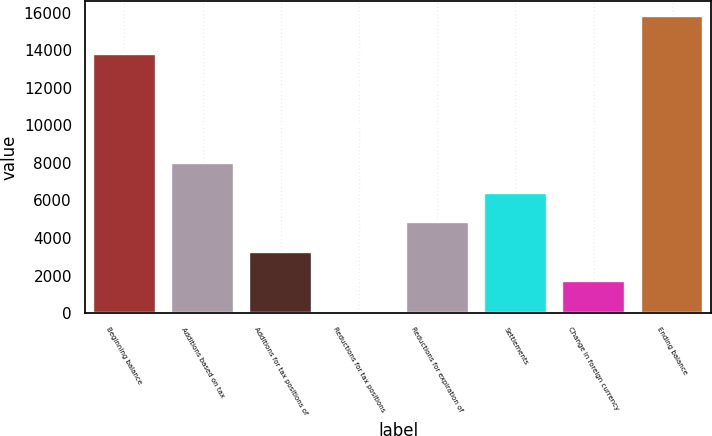<chart> <loc_0><loc_0><loc_500><loc_500><bar_chart><fcel>Beginning balance<fcel>Additions based on tax<fcel>Additions for tax positions of<fcel>Reductions for tax positions<fcel>Reductions for expiration of<fcel>Settlements<fcel>Change in foreign currency<fcel>Ending balance<nl><fcel>13804<fcel>7980.5<fcel>3274.4<fcel>137<fcel>4843.1<fcel>6411.8<fcel>1705.7<fcel>15824<nl></chart> 